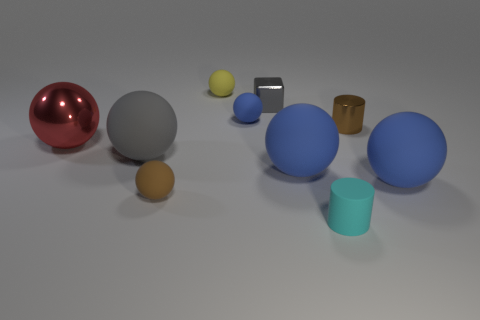There is a object that is the same color as the small metal block; what is it made of?
Provide a succinct answer. Rubber. There is a cylinder that is made of the same material as the tiny blue thing; what is its color?
Your answer should be compact. Cyan. What number of large things are either blue rubber things or metal things?
Your answer should be very brief. 3. There is a small yellow rubber sphere; how many matte balls are in front of it?
Provide a succinct answer. 5. What color is the other big metallic thing that is the same shape as the yellow object?
Offer a terse response. Red. What number of metallic things are either big gray spheres or green spheres?
Provide a short and direct response. 0. Are there any small blocks that are behind the tiny cylinder on the left side of the small cylinder behind the big metal thing?
Ensure brevity in your answer.  Yes. What color is the matte cylinder?
Ensure brevity in your answer.  Cyan. There is a small brown shiny thing that is right of the gray rubber thing; is its shape the same as the big gray rubber object?
Offer a very short reply. No. What number of objects are small shiny cylinders or blue rubber objects that are to the left of the tiny gray shiny object?
Your response must be concise. 2. 